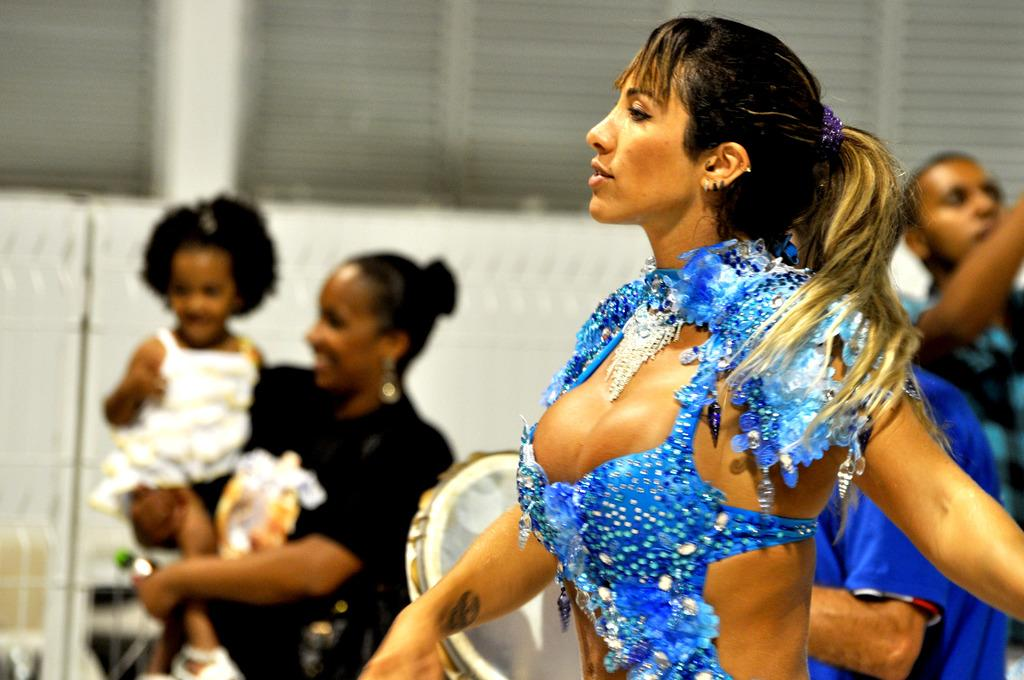Who is the main subject in the image? There is a woman in the image. What is the woman wearing? The woman is wearing a blue dress. Are there any distinguishing features on the woman's body? Yes, the woman has a tattoo on her hand. What can be seen in the background of the image? There are people, a drum, and a wall in the background of the image. What is the woman doing in the image? A woman is holding a kid in the image. Is there a rainstorm happening in the image? No, there is no indication of a rainstorm in the image. Can you see any worms in the image? No, there are no worms present in the image. 